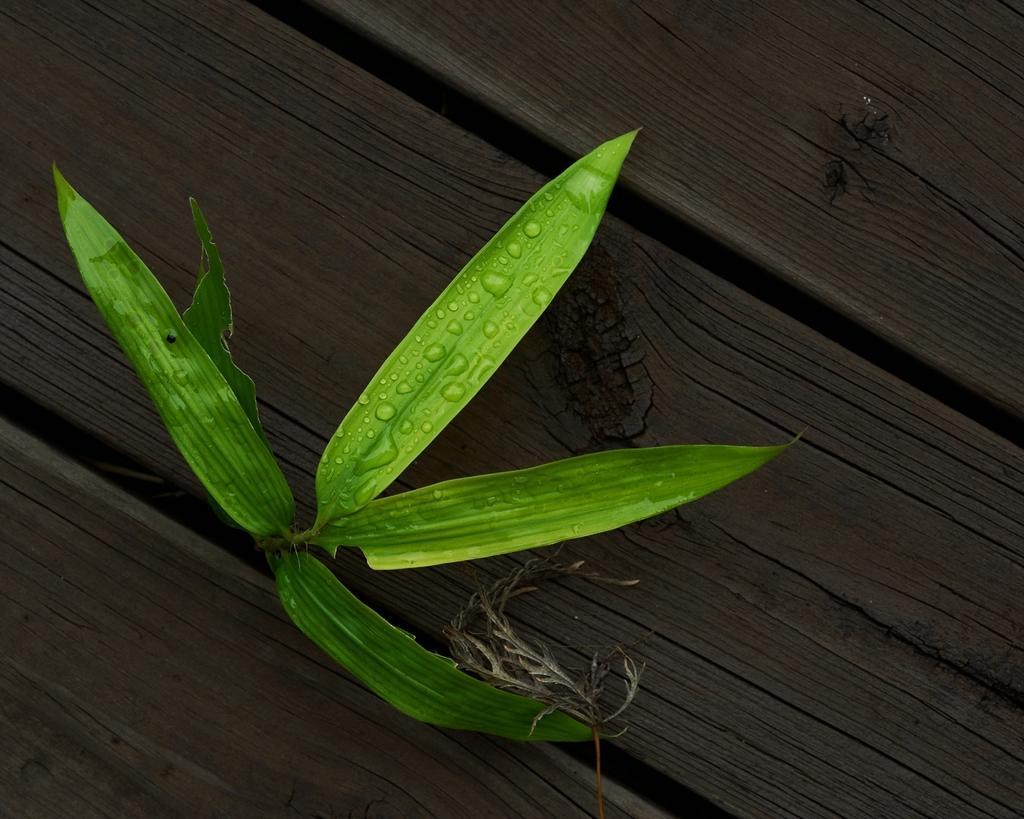In one or two sentences, can you explain what this image depicts? In the image there is wooden surface and in between two woods there is a plant with green leaves. 